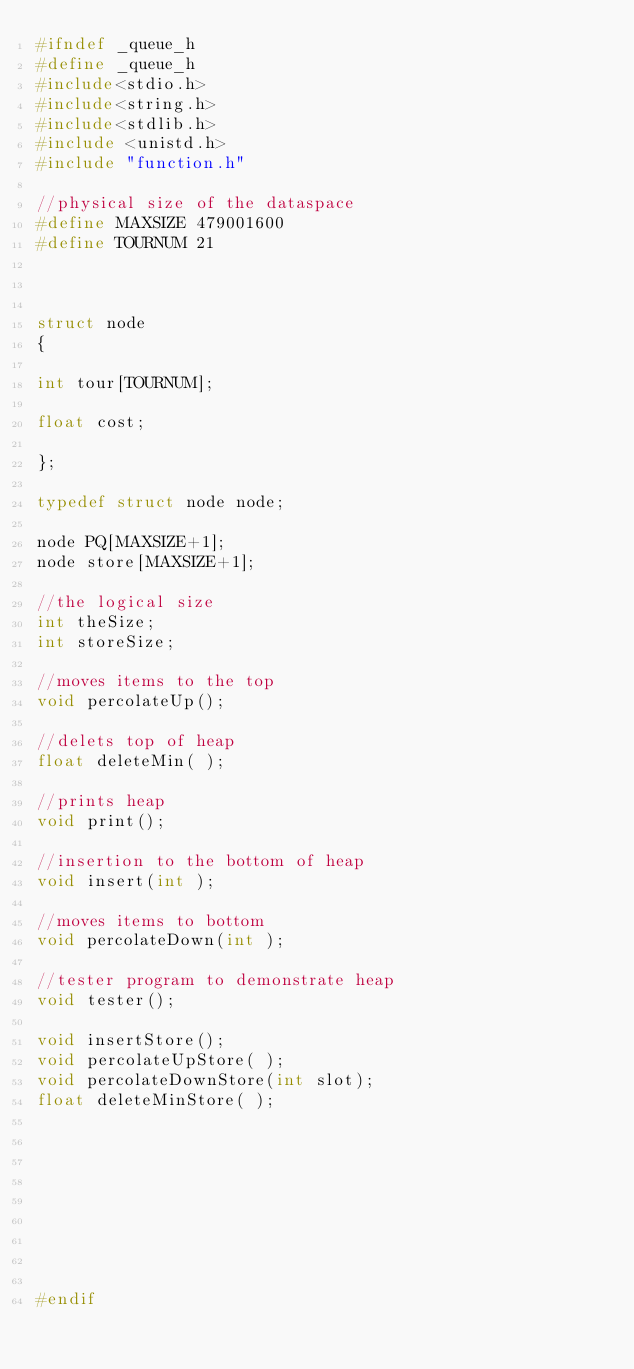Convert code to text. <code><loc_0><loc_0><loc_500><loc_500><_C_>#ifndef _queue_h
#define _queue_h
#include<stdio.h>
#include<string.h>
#include<stdlib.h>
#include <unistd.h>
#include "function.h"

//physical size of the dataspace
#define MAXSIZE 479001600
#define TOURNUM 21



struct node
{

int tour[TOURNUM];

float cost;

};

typedef struct node node;

node PQ[MAXSIZE+1];
node store[MAXSIZE+1];

//the logical size
int theSize;
int storeSize;

//moves items to the top
void percolateUp();

//delets top of heap
float deleteMin( );

//prints heap
void print();

//insertion to the bottom of heap
void insert(int );

//moves items to bottom
void percolateDown(int );

//tester program to demonstrate heap
void tester();

void insertStore();
void percolateUpStore( );
void percolateDownStore(int slot);
float deleteMinStore( );









#endif
</code> 